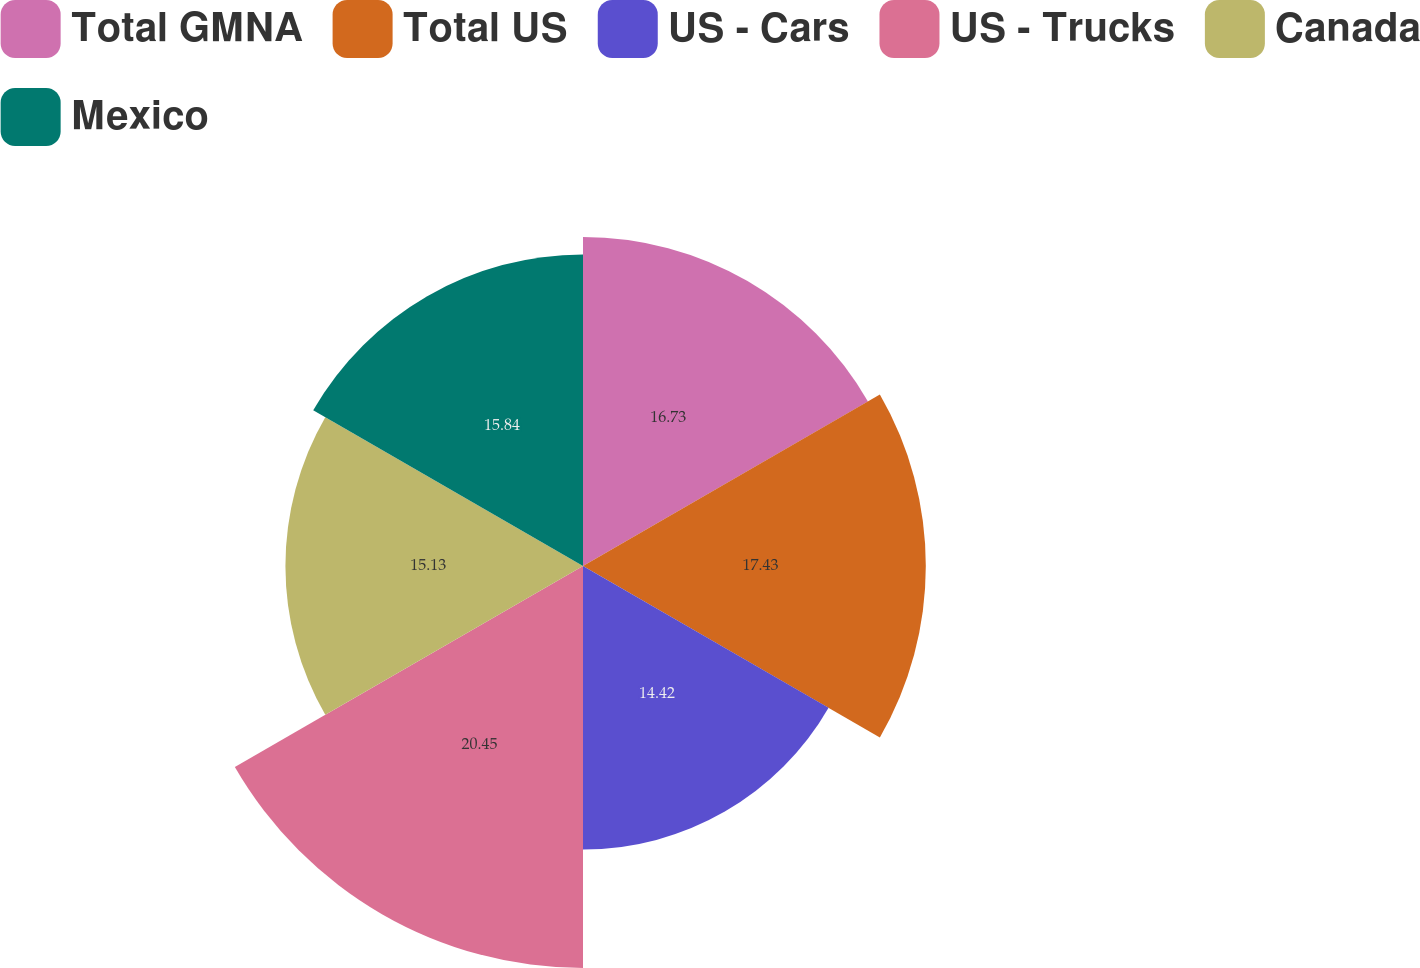Convert chart. <chart><loc_0><loc_0><loc_500><loc_500><pie_chart><fcel>Total GMNA<fcel>Total US<fcel>US - Cars<fcel>US - Trucks<fcel>Canada<fcel>Mexico<nl><fcel>16.73%<fcel>17.43%<fcel>14.42%<fcel>20.44%<fcel>15.13%<fcel>15.84%<nl></chart> 